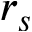<formula> <loc_0><loc_0><loc_500><loc_500>r _ { s }</formula> 